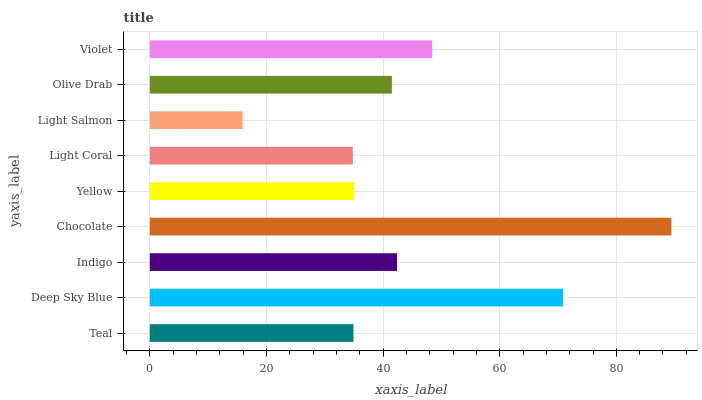Is Light Salmon the minimum?
Answer yes or no. Yes. Is Chocolate the maximum?
Answer yes or no. Yes. Is Deep Sky Blue the minimum?
Answer yes or no. No. Is Deep Sky Blue the maximum?
Answer yes or no. No. Is Deep Sky Blue greater than Teal?
Answer yes or no. Yes. Is Teal less than Deep Sky Blue?
Answer yes or no. Yes. Is Teal greater than Deep Sky Blue?
Answer yes or no. No. Is Deep Sky Blue less than Teal?
Answer yes or no. No. Is Olive Drab the high median?
Answer yes or no. Yes. Is Olive Drab the low median?
Answer yes or no. Yes. Is Violet the high median?
Answer yes or no. No. Is Teal the low median?
Answer yes or no. No. 